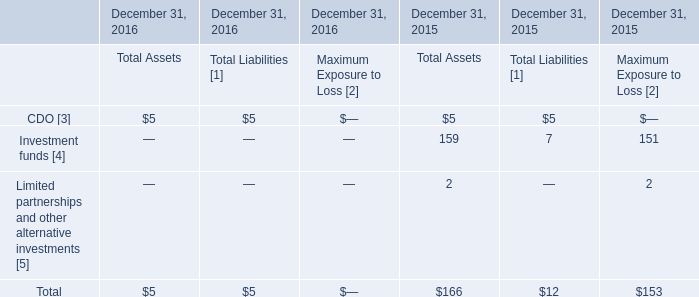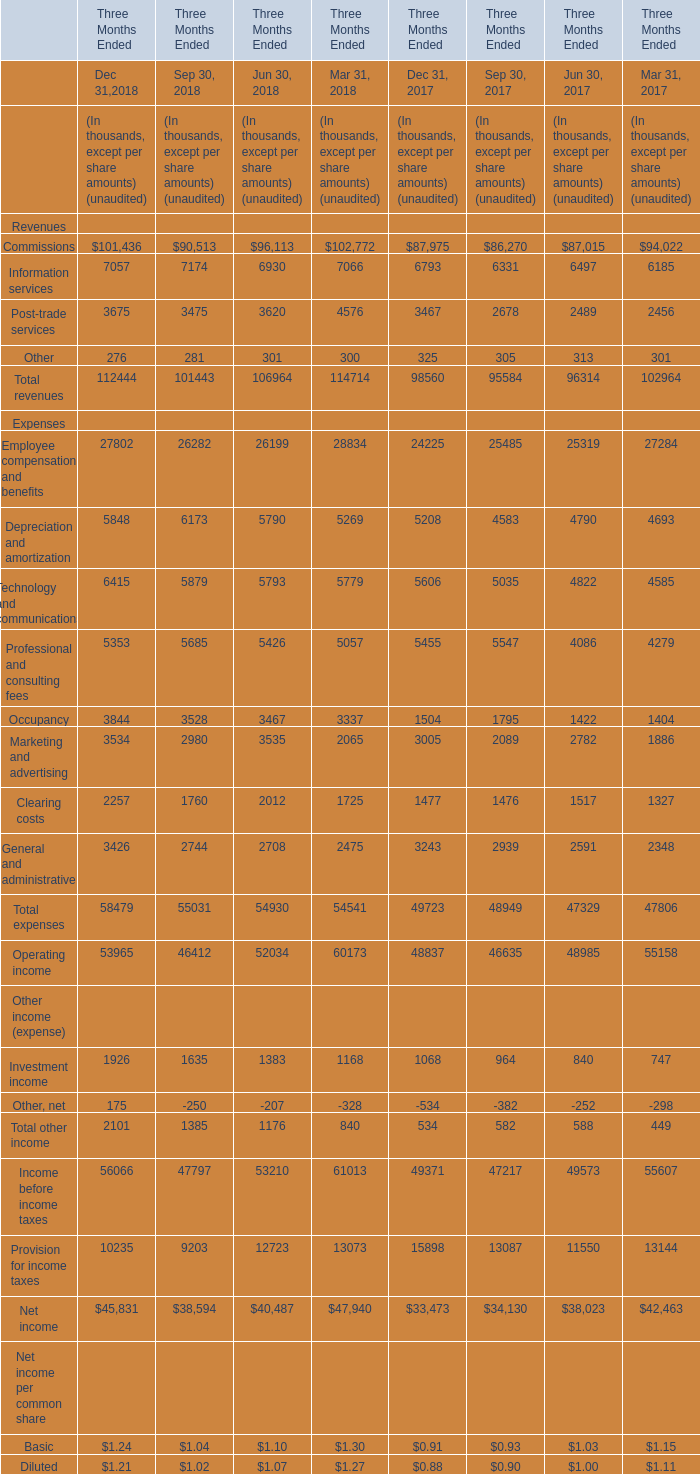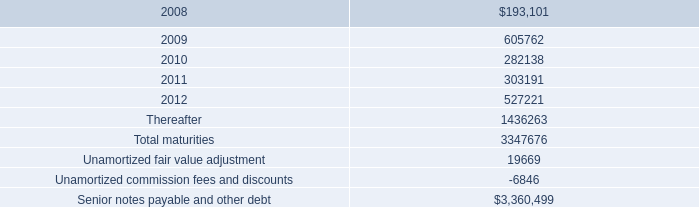What's the greatest value of Dec 31 in 2018? (in thousand) 
Answer: 101436. 